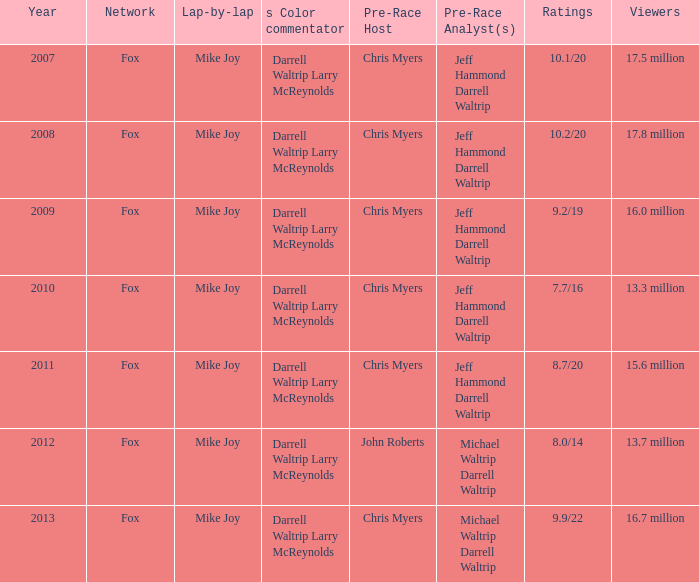What Lap-by-lap has Chris Myers as the Pre-Race Host, a Year larger than 2008, and 9.9/22 as its Ratings? Mike Joy. 